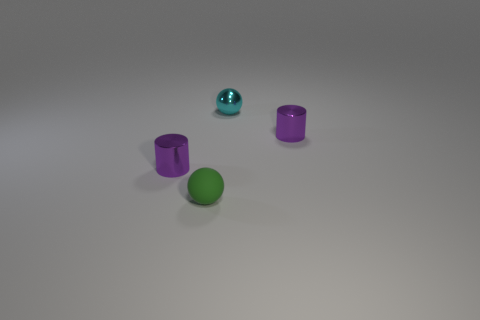How many small matte balls are the same color as the small rubber thing?
Provide a succinct answer. 0. Does the small green matte object have the same shape as the tiny cyan object?
Offer a very short reply. Yes. Is there any other thing that has the same size as the shiny ball?
Keep it short and to the point. Yes. What size is the green object that is the same shape as the tiny cyan thing?
Keep it short and to the point. Small. Is the number of green matte spheres to the right of the small rubber thing greater than the number of green rubber balls that are behind the tiny cyan sphere?
Ensure brevity in your answer.  No. Do the small green ball and the cylinder left of the metallic ball have the same material?
Offer a terse response. No. Is there anything else that is the same shape as the rubber thing?
Make the answer very short. Yes. What color is the metallic object that is both in front of the metal ball and right of the tiny rubber thing?
Ensure brevity in your answer.  Purple. There is a tiny purple metallic object to the left of the cyan shiny sphere; what shape is it?
Give a very brief answer. Cylinder. How big is the purple object that is on the left side of the tiny cyan sphere that is to the right of the tiny rubber thing that is to the left of the small shiny ball?
Give a very brief answer. Small. 